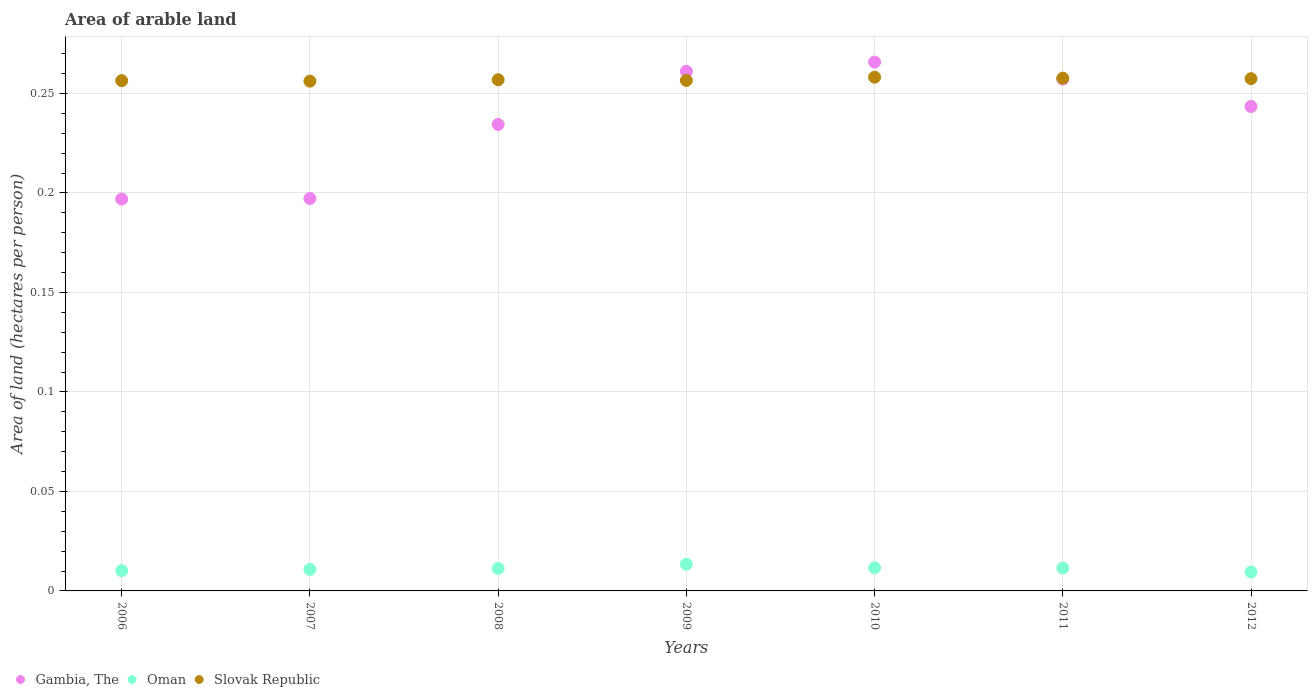What is the total arable land in Oman in 2008?
Keep it short and to the point. 0.01. Across all years, what is the maximum total arable land in Oman?
Ensure brevity in your answer.  0.01. Across all years, what is the minimum total arable land in Slovak Republic?
Keep it short and to the point. 0.26. What is the total total arable land in Oman in the graph?
Provide a short and direct response. 0.08. What is the difference between the total arable land in Oman in 2007 and that in 2008?
Make the answer very short. -0. What is the difference between the total arable land in Oman in 2006 and the total arable land in Slovak Republic in 2011?
Make the answer very short. -0.25. What is the average total arable land in Slovak Republic per year?
Make the answer very short. 0.26. In the year 2007, what is the difference between the total arable land in Oman and total arable land in Slovak Republic?
Your answer should be compact. -0.25. In how many years, is the total arable land in Slovak Republic greater than 0.15000000000000002 hectares per person?
Give a very brief answer. 7. What is the ratio of the total arable land in Gambia, The in 2007 to that in 2011?
Your answer should be very brief. 0.77. What is the difference between the highest and the second highest total arable land in Oman?
Your answer should be very brief. 0. What is the difference between the highest and the lowest total arable land in Slovak Republic?
Give a very brief answer. 0. In how many years, is the total arable land in Slovak Republic greater than the average total arable land in Slovak Republic taken over all years?
Provide a succinct answer. 3. Is the sum of the total arable land in Slovak Republic in 2008 and 2012 greater than the maximum total arable land in Oman across all years?
Offer a terse response. Yes. Is the total arable land in Slovak Republic strictly greater than the total arable land in Gambia, The over the years?
Your response must be concise. No. Is the total arable land in Oman strictly less than the total arable land in Slovak Republic over the years?
Make the answer very short. Yes. How many years are there in the graph?
Give a very brief answer. 7. What is the difference between two consecutive major ticks on the Y-axis?
Offer a terse response. 0.05. Are the values on the major ticks of Y-axis written in scientific E-notation?
Offer a terse response. No. Does the graph contain any zero values?
Provide a succinct answer. No. Does the graph contain grids?
Offer a terse response. Yes. Where does the legend appear in the graph?
Your answer should be compact. Bottom left. What is the title of the graph?
Your response must be concise. Area of arable land. Does "Guam" appear as one of the legend labels in the graph?
Provide a short and direct response. No. What is the label or title of the Y-axis?
Make the answer very short. Area of land (hectares per person). What is the Area of land (hectares per person) of Gambia, The in 2006?
Your answer should be compact. 0.2. What is the Area of land (hectares per person) in Oman in 2006?
Provide a short and direct response. 0.01. What is the Area of land (hectares per person) of Slovak Republic in 2006?
Offer a terse response. 0.26. What is the Area of land (hectares per person) in Gambia, The in 2007?
Make the answer very short. 0.2. What is the Area of land (hectares per person) of Oman in 2007?
Provide a short and direct response. 0.01. What is the Area of land (hectares per person) of Slovak Republic in 2007?
Provide a succinct answer. 0.26. What is the Area of land (hectares per person) of Gambia, The in 2008?
Provide a short and direct response. 0.23. What is the Area of land (hectares per person) in Oman in 2008?
Provide a short and direct response. 0.01. What is the Area of land (hectares per person) of Slovak Republic in 2008?
Provide a succinct answer. 0.26. What is the Area of land (hectares per person) of Gambia, The in 2009?
Ensure brevity in your answer.  0.26. What is the Area of land (hectares per person) of Oman in 2009?
Offer a terse response. 0.01. What is the Area of land (hectares per person) of Slovak Republic in 2009?
Keep it short and to the point. 0.26. What is the Area of land (hectares per person) of Gambia, The in 2010?
Provide a short and direct response. 0.27. What is the Area of land (hectares per person) of Oman in 2010?
Ensure brevity in your answer.  0.01. What is the Area of land (hectares per person) of Slovak Republic in 2010?
Make the answer very short. 0.26. What is the Area of land (hectares per person) in Gambia, The in 2011?
Give a very brief answer. 0.26. What is the Area of land (hectares per person) in Oman in 2011?
Make the answer very short. 0.01. What is the Area of land (hectares per person) of Slovak Republic in 2011?
Provide a short and direct response. 0.26. What is the Area of land (hectares per person) in Gambia, The in 2012?
Offer a very short reply. 0.24. What is the Area of land (hectares per person) in Oman in 2012?
Ensure brevity in your answer.  0.01. What is the Area of land (hectares per person) of Slovak Republic in 2012?
Make the answer very short. 0.26. Across all years, what is the maximum Area of land (hectares per person) in Gambia, The?
Keep it short and to the point. 0.27. Across all years, what is the maximum Area of land (hectares per person) in Oman?
Provide a succinct answer. 0.01. Across all years, what is the maximum Area of land (hectares per person) in Slovak Republic?
Give a very brief answer. 0.26. Across all years, what is the minimum Area of land (hectares per person) in Gambia, The?
Make the answer very short. 0.2. Across all years, what is the minimum Area of land (hectares per person) of Oman?
Give a very brief answer. 0.01. Across all years, what is the minimum Area of land (hectares per person) of Slovak Republic?
Offer a terse response. 0.26. What is the total Area of land (hectares per person) in Gambia, The in the graph?
Your answer should be very brief. 1.66. What is the total Area of land (hectares per person) of Oman in the graph?
Ensure brevity in your answer.  0.08. What is the total Area of land (hectares per person) in Slovak Republic in the graph?
Provide a short and direct response. 1.8. What is the difference between the Area of land (hectares per person) of Gambia, The in 2006 and that in 2007?
Keep it short and to the point. -0. What is the difference between the Area of land (hectares per person) of Oman in 2006 and that in 2007?
Give a very brief answer. -0. What is the difference between the Area of land (hectares per person) in Gambia, The in 2006 and that in 2008?
Keep it short and to the point. -0.04. What is the difference between the Area of land (hectares per person) of Oman in 2006 and that in 2008?
Ensure brevity in your answer.  -0. What is the difference between the Area of land (hectares per person) of Slovak Republic in 2006 and that in 2008?
Keep it short and to the point. -0. What is the difference between the Area of land (hectares per person) of Gambia, The in 2006 and that in 2009?
Your answer should be compact. -0.06. What is the difference between the Area of land (hectares per person) in Oman in 2006 and that in 2009?
Your response must be concise. -0. What is the difference between the Area of land (hectares per person) of Slovak Republic in 2006 and that in 2009?
Offer a terse response. -0. What is the difference between the Area of land (hectares per person) of Gambia, The in 2006 and that in 2010?
Your answer should be compact. -0.07. What is the difference between the Area of land (hectares per person) in Oman in 2006 and that in 2010?
Offer a terse response. -0. What is the difference between the Area of land (hectares per person) in Slovak Republic in 2006 and that in 2010?
Provide a short and direct response. -0. What is the difference between the Area of land (hectares per person) in Gambia, The in 2006 and that in 2011?
Keep it short and to the point. -0.06. What is the difference between the Area of land (hectares per person) in Oman in 2006 and that in 2011?
Give a very brief answer. -0. What is the difference between the Area of land (hectares per person) in Slovak Republic in 2006 and that in 2011?
Keep it short and to the point. -0. What is the difference between the Area of land (hectares per person) of Gambia, The in 2006 and that in 2012?
Provide a short and direct response. -0.05. What is the difference between the Area of land (hectares per person) of Oman in 2006 and that in 2012?
Keep it short and to the point. 0. What is the difference between the Area of land (hectares per person) of Slovak Republic in 2006 and that in 2012?
Your answer should be compact. -0. What is the difference between the Area of land (hectares per person) in Gambia, The in 2007 and that in 2008?
Your response must be concise. -0.04. What is the difference between the Area of land (hectares per person) of Oman in 2007 and that in 2008?
Keep it short and to the point. -0. What is the difference between the Area of land (hectares per person) of Slovak Republic in 2007 and that in 2008?
Provide a succinct answer. -0. What is the difference between the Area of land (hectares per person) of Gambia, The in 2007 and that in 2009?
Make the answer very short. -0.06. What is the difference between the Area of land (hectares per person) of Oman in 2007 and that in 2009?
Make the answer very short. -0. What is the difference between the Area of land (hectares per person) of Slovak Republic in 2007 and that in 2009?
Provide a succinct answer. -0. What is the difference between the Area of land (hectares per person) in Gambia, The in 2007 and that in 2010?
Offer a terse response. -0.07. What is the difference between the Area of land (hectares per person) of Oman in 2007 and that in 2010?
Make the answer very short. -0. What is the difference between the Area of land (hectares per person) of Slovak Republic in 2007 and that in 2010?
Your response must be concise. -0. What is the difference between the Area of land (hectares per person) of Gambia, The in 2007 and that in 2011?
Ensure brevity in your answer.  -0.06. What is the difference between the Area of land (hectares per person) in Oman in 2007 and that in 2011?
Provide a succinct answer. -0. What is the difference between the Area of land (hectares per person) of Slovak Republic in 2007 and that in 2011?
Give a very brief answer. -0. What is the difference between the Area of land (hectares per person) in Gambia, The in 2007 and that in 2012?
Offer a very short reply. -0.05. What is the difference between the Area of land (hectares per person) in Oman in 2007 and that in 2012?
Offer a very short reply. 0. What is the difference between the Area of land (hectares per person) in Slovak Republic in 2007 and that in 2012?
Your answer should be very brief. -0. What is the difference between the Area of land (hectares per person) of Gambia, The in 2008 and that in 2009?
Give a very brief answer. -0.03. What is the difference between the Area of land (hectares per person) of Oman in 2008 and that in 2009?
Provide a short and direct response. -0. What is the difference between the Area of land (hectares per person) in Gambia, The in 2008 and that in 2010?
Provide a succinct answer. -0.03. What is the difference between the Area of land (hectares per person) in Oman in 2008 and that in 2010?
Your response must be concise. -0. What is the difference between the Area of land (hectares per person) of Slovak Republic in 2008 and that in 2010?
Provide a short and direct response. -0. What is the difference between the Area of land (hectares per person) of Gambia, The in 2008 and that in 2011?
Your answer should be compact. -0.02. What is the difference between the Area of land (hectares per person) of Oman in 2008 and that in 2011?
Your answer should be very brief. -0. What is the difference between the Area of land (hectares per person) in Slovak Republic in 2008 and that in 2011?
Provide a succinct answer. -0. What is the difference between the Area of land (hectares per person) of Gambia, The in 2008 and that in 2012?
Give a very brief answer. -0.01. What is the difference between the Area of land (hectares per person) of Oman in 2008 and that in 2012?
Provide a short and direct response. 0. What is the difference between the Area of land (hectares per person) of Slovak Republic in 2008 and that in 2012?
Your answer should be very brief. -0. What is the difference between the Area of land (hectares per person) in Gambia, The in 2009 and that in 2010?
Offer a terse response. -0. What is the difference between the Area of land (hectares per person) of Oman in 2009 and that in 2010?
Your response must be concise. 0. What is the difference between the Area of land (hectares per person) in Slovak Republic in 2009 and that in 2010?
Make the answer very short. -0. What is the difference between the Area of land (hectares per person) in Gambia, The in 2009 and that in 2011?
Ensure brevity in your answer.  0. What is the difference between the Area of land (hectares per person) of Oman in 2009 and that in 2011?
Your response must be concise. 0. What is the difference between the Area of land (hectares per person) in Slovak Republic in 2009 and that in 2011?
Offer a terse response. -0. What is the difference between the Area of land (hectares per person) of Gambia, The in 2009 and that in 2012?
Offer a very short reply. 0.02. What is the difference between the Area of land (hectares per person) in Oman in 2009 and that in 2012?
Provide a short and direct response. 0. What is the difference between the Area of land (hectares per person) of Slovak Republic in 2009 and that in 2012?
Your answer should be very brief. -0. What is the difference between the Area of land (hectares per person) in Gambia, The in 2010 and that in 2011?
Ensure brevity in your answer.  0.01. What is the difference between the Area of land (hectares per person) of Gambia, The in 2010 and that in 2012?
Offer a terse response. 0.02. What is the difference between the Area of land (hectares per person) in Oman in 2010 and that in 2012?
Provide a short and direct response. 0. What is the difference between the Area of land (hectares per person) in Slovak Republic in 2010 and that in 2012?
Offer a very short reply. 0. What is the difference between the Area of land (hectares per person) of Gambia, The in 2011 and that in 2012?
Provide a short and direct response. 0.01. What is the difference between the Area of land (hectares per person) of Oman in 2011 and that in 2012?
Your answer should be compact. 0. What is the difference between the Area of land (hectares per person) in Slovak Republic in 2011 and that in 2012?
Your answer should be very brief. 0. What is the difference between the Area of land (hectares per person) in Gambia, The in 2006 and the Area of land (hectares per person) in Oman in 2007?
Ensure brevity in your answer.  0.19. What is the difference between the Area of land (hectares per person) of Gambia, The in 2006 and the Area of land (hectares per person) of Slovak Republic in 2007?
Offer a very short reply. -0.06. What is the difference between the Area of land (hectares per person) in Oman in 2006 and the Area of land (hectares per person) in Slovak Republic in 2007?
Give a very brief answer. -0.25. What is the difference between the Area of land (hectares per person) of Gambia, The in 2006 and the Area of land (hectares per person) of Oman in 2008?
Make the answer very short. 0.19. What is the difference between the Area of land (hectares per person) of Gambia, The in 2006 and the Area of land (hectares per person) of Slovak Republic in 2008?
Make the answer very short. -0.06. What is the difference between the Area of land (hectares per person) in Oman in 2006 and the Area of land (hectares per person) in Slovak Republic in 2008?
Your answer should be very brief. -0.25. What is the difference between the Area of land (hectares per person) of Gambia, The in 2006 and the Area of land (hectares per person) of Oman in 2009?
Your response must be concise. 0.18. What is the difference between the Area of land (hectares per person) in Gambia, The in 2006 and the Area of land (hectares per person) in Slovak Republic in 2009?
Your answer should be very brief. -0.06. What is the difference between the Area of land (hectares per person) of Oman in 2006 and the Area of land (hectares per person) of Slovak Republic in 2009?
Keep it short and to the point. -0.25. What is the difference between the Area of land (hectares per person) in Gambia, The in 2006 and the Area of land (hectares per person) in Oman in 2010?
Offer a terse response. 0.19. What is the difference between the Area of land (hectares per person) of Gambia, The in 2006 and the Area of land (hectares per person) of Slovak Republic in 2010?
Your answer should be very brief. -0.06. What is the difference between the Area of land (hectares per person) in Oman in 2006 and the Area of land (hectares per person) in Slovak Republic in 2010?
Make the answer very short. -0.25. What is the difference between the Area of land (hectares per person) of Gambia, The in 2006 and the Area of land (hectares per person) of Oman in 2011?
Ensure brevity in your answer.  0.19. What is the difference between the Area of land (hectares per person) of Gambia, The in 2006 and the Area of land (hectares per person) of Slovak Republic in 2011?
Provide a succinct answer. -0.06. What is the difference between the Area of land (hectares per person) of Oman in 2006 and the Area of land (hectares per person) of Slovak Republic in 2011?
Keep it short and to the point. -0.25. What is the difference between the Area of land (hectares per person) in Gambia, The in 2006 and the Area of land (hectares per person) in Oman in 2012?
Provide a short and direct response. 0.19. What is the difference between the Area of land (hectares per person) in Gambia, The in 2006 and the Area of land (hectares per person) in Slovak Republic in 2012?
Your response must be concise. -0.06. What is the difference between the Area of land (hectares per person) in Oman in 2006 and the Area of land (hectares per person) in Slovak Republic in 2012?
Offer a terse response. -0.25. What is the difference between the Area of land (hectares per person) in Gambia, The in 2007 and the Area of land (hectares per person) in Oman in 2008?
Make the answer very short. 0.19. What is the difference between the Area of land (hectares per person) in Gambia, The in 2007 and the Area of land (hectares per person) in Slovak Republic in 2008?
Make the answer very short. -0.06. What is the difference between the Area of land (hectares per person) in Oman in 2007 and the Area of land (hectares per person) in Slovak Republic in 2008?
Your answer should be very brief. -0.25. What is the difference between the Area of land (hectares per person) in Gambia, The in 2007 and the Area of land (hectares per person) in Oman in 2009?
Ensure brevity in your answer.  0.18. What is the difference between the Area of land (hectares per person) of Gambia, The in 2007 and the Area of land (hectares per person) of Slovak Republic in 2009?
Offer a very short reply. -0.06. What is the difference between the Area of land (hectares per person) of Oman in 2007 and the Area of land (hectares per person) of Slovak Republic in 2009?
Provide a succinct answer. -0.25. What is the difference between the Area of land (hectares per person) of Gambia, The in 2007 and the Area of land (hectares per person) of Oman in 2010?
Provide a succinct answer. 0.19. What is the difference between the Area of land (hectares per person) of Gambia, The in 2007 and the Area of land (hectares per person) of Slovak Republic in 2010?
Your answer should be compact. -0.06. What is the difference between the Area of land (hectares per person) in Oman in 2007 and the Area of land (hectares per person) in Slovak Republic in 2010?
Your answer should be very brief. -0.25. What is the difference between the Area of land (hectares per person) in Gambia, The in 2007 and the Area of land (hectares per person) in Oman in 2011?
Provide a short and direct response. 0.19. What is the difference between the Area of land (hectares per person) in Gambia, The in 2007 and the Area of land (hectares per person) in Slovak Republic in 2011?
Give a very brief answer. -0.06. What is the difference between the Area of land (hectares per person) in Oman in 2007 and the Area of land (hectares per person) in Slovak Republic in 2011?
Make the answer very short. -0.25. What is the difference between the Area of land (hectares per person) in Gambia, The in 2007 and the Area of land (hectares per person) in Oman in 2012?
Make the answer very short. 0.19. What is the difference between the Area of land (hectares per person) of Gambia, The in 2007 and the Area of land (hectares per person) of Slovak Republic in 2012?
Ensure brevity in your answer.  -0.06. What is the difference between the Area of land (hectares per person) of Oman in 2007 and the Area of land (hectares per person) of Slovak Republic in 2012?
Provide a succinct answer. -0.25. What is the difference between the Area of land (hectares per person) of Gambia, The in 2008 and the Area of land (hectares per person) of Oman in 2009?
Ensure brevity in your answer.  0.22. What is the difference between the Area of land (hectares per person) of Gambia, The in 2008 and the Area of land (hectares per person) of Slovak Republic in 2009?
Your answer should be very brief. -0.02. What is the difference between the Area of land (hectares per person) of Oman in 2008 and the Area of land (hectares per person) of Slovak Republic in 2009?
Your response must be concise. -0.25. What is the difference between the Area of land (hectares per person) of Gambia, The in 2008 and the Area of land (hectares per person) of Oman in 2010?
Ensure brevity in your answer.  0.22. What is the difference between the Area of land (hectares per person) of Gambia, The in 2008 and the Area of land (hectares per person) of Slovak Republic in 2010?
Keep it short and to the point. -0.02. What is the difference between the Area of land (hectares per person) of Oman in 2008 and the Area of land (hectares per person) of Slovak Republic in 2010?
Your answer should be compact. -0.25. What is the difference between the Area of land (hectares per person) in Gambia, The in 2008 and the Area of land (hectares per person) in Oman in 2011?
Provide a short and direct response. 0.22. What is the difference between the Area of land (hectares per person) in Gambia, The in 2008 and the Area of land (hectares per person) in Slovak Republic in 2011?
Ensure brevity in your answer.  -0.02. What is the difference between the Area of land (hectares per person) in Oman in 2008 and the Area of land (hectares per person) in Slovak Republic in 2011?
Your answer should be compact. -0.25. What is the difference between the Area of land (hectares per person) in Gambia, The in 2008 and the Area of land (hectares per person) in Oman in 2012?
Give a very brief answer. 0.22. What is the difference between the Area of land (hectares per person) of Gambia, The in 2008 and the Area of land (hectares per person) of Slovak Republic in 2012?
Your answer should be very brief. -0.02. What is the difference between the Area of land (hectares per person) of Oman in 2008 and the Area of land (hectares per person) of Slovak Republic in 2012?
Give a very brief answer. -0.25. What is the difference between the Area of land (hectares per person) in Gambia, The in 2009 and the Area of land (hectares per person) in Oman in 2010?
Offer a terse response. 0.25. What is the difference between the Area of land (hectares per person) of Gambia, The in 2009 and the Area of land (hectares per person) of Slovak Republic in 2010?
Your answer should be compact. 0. What is the difference between the Area of land (hectares per person) in Oman in 2009 and the Area of land (hectares per person) in Slovak Republic in 2010?
Provide a short and direct response. -0.24. What is the difference between the Area of land (hectares per person) of Gambia, The in 2009 and the Area of land (hectares per person) of Oman in 2011?
Your answer should be very brief. 0.25. What is the difference between the Area of land (hectares per person) in Gambia, The in 2009 and the Area of land (hectares per person) in Slovak Republic in 2011?
Your answer should be compact. 0. What is the difference between the Area of land (hectares per person) in Oman in 2009 and the Area of land (hectares per person) in Slovak Republic in 2011?
Keep it short and to the point. -0.24. What is the difference between the Area of land (hectares per person) in Gambia, The in 2009 and the Area of land (hectares per person) in Oman in 2012?
Keep it short and to the point. 0.25. What is the difference between the Area of land (hectares per person) in Gambia, The in 2009 and the Area of land (hectares per person) in Slovak Republic in 2012?
Give a very brief answer. 0. What is the difference between the Area of land (hectares per person) of Oman in 2009 and the Area of land (hectares per person) of Slovak Republic in 2012?
Offer a terse response. -0.24. What is the difference between the Area of land (hectares per person) of Gambia, The in 2010 and the Area of land (hectares per person) of Oman in 2011?
Ensure brevity in your answer.  0.25. What is the difference between the Area of land (hectares per person) in Gambia, The in 2010 and the Area of land (hectares per person) in Slovak Republic in 2011?
Your answer should be compact. 0.01. What is the difference between the Area of land (hectares per person) in Oman in 2010 and the Area of land (hectares per person) in Slovak Republic in 2011?
Provide a succinct answer. -0.25. What is the difference between the Area of land (hectares per person) of Gambia, The in 2010 and the Area of land (hectares per person) of Oman in 2012?
Ensure brevity in your answer.  0.26. What is the difference between the Area of land (hectares per person) of Gambia, The in 2010 and the Area of land (hectares per person) of Slovak Republic in 2012?
Make the answer very short. 0.01. What is the difference between the Area of land (hectares per person) in Oman in 2010 and the Area of land (hectares per person) in Slovak Republic in 2012?
Make the answer very short. -0.25. What is the difference between the Area of land (hectares per person) in Gambia, The in 2011 and the Area of land (hectares per person) in Oman in 2012?
Give a very brief answer. 0.25. What is the difference between the Area of land (hectares per person) of Gambia, The in 2011 and the Area of land (hectares per person) of Slovak Republic in 2012?
Your answer should be compact. -0. What is the difference between the Area of land (hectares per person) in Oman in 2011 and the Area of land (hectares per person) in Slovak Republic in 2012?
Offer a terse response. -0.25. What is the average Area of land (hectares per person) of Gambia, The per year?
Keep it short and to the point. 0.24. What is the average Area of land (hectares per person) of Oman per year?
Offer a very short reply. 0.01. What is the average Area of land (hectares per person) in Slovak Republic per year?
Ensure brevity in your answer.  0.26. In the year 2006, what is the difference between the Area of land (hectares per person) in Gambia, The and Area of land (hectares per person) in Oman?
Make the answer very short. 0.19. In the year 2006, what is the difference between the Area of land (hectares per person) of Gambia, The and Area of land (hectares per person) of Slovak Republic?
Provide a succinct answer. -0.06. In the year 2006, what is the difference between the Area of land (hectares per person) in Oman and Area of land (hectares per person) in Slovak Republic?
Provide a succinct answer. -0.25. In the year 2007, what is the difference between the Area of land (hectares per person) of Gambia, The and Area of land (hectares per person) of Oman?
Make the answer very short. 0.19. In the year 2007, what is the difference between the Area of land (hectares per person) of Gambia, The and Area of land (hectares per person) of Slovak Republic?
Provide a succinct answer. -0.06. In the year 2007, what is the difference between the Area of land (hectares per person) of Oman and Area of land (hectares per person) of Slovak Republic?
Keep it short and to the point. -0.25. In the year 2008, what is the difference between the Area of land (hectares per person) in Gambia, The and Area of land (hectares per person) in Oman?
Make the answer very short. 0.22. In the year 2008, what is the difference between the Area of land (hectares per person) in Gambia, The and Area of land (hectares per person) in Slovak Republic?
Offer a terse response. -0.02. In the year 2008, what is the difference between the Area of land (hectares per person) of Oman and Area of land (hectares per person) of Slovak Republic?
Ensure brevity in your answer.  -0.25. In the year 2009, what is the difference between the Area of land (hectares per person) in Gambia, The and Area of land (hectares per person) in Oman?
Give a very brief answer. 0.25. In the year 2009, what is the difference between the Area of land (hectares per person) in Gambia, The and Area of land (hectares per person) in Slovak Republic?
Provide a short and direct response. 0. In the year 2009, what is the difference between the Area of land (hectares per person) of Oman and Area of land (hectares per person) of Slovak Republic?
Make the answer very short. -0.24. In the year 2010, what is the difference between the Area of land (hectares per person) of Gambia, The and Area of land (hectares per person) of Oman?
Provide a short and direct response. 0.25. In the year 2010, what is the difference between the Area of land (hectares per person) of Gambia, The and Area of land (hectares per person) of Slovak Republic?
Give a very brief answer. 0.01. In the year 2010, what is the difference between the Area of land (hectares per person) of Oman and Area of land (hectares per person) of Slovak Republic?
Offer a terse response. -0.25. In the year 2011, what is the difference between the Area of land (hectares per person) of Gambia, The and Area of land (hectares per person) of Oman?
Your response must be concise. 0.25. In the year 2011, what is the difference between the Area of land (hectares per person) in Gambia, The and Area of land (hectares per person) in Slovak Republic?
Keep it short and to the point. -0. In the year 2011, what is the difference between the Area of land (hectares per person) of Oman and Area of land (hectares per person) of Slovak Republic?
Offer a terse response. -0.25. In the year 2012, what is the difference between the Area of land (hectares per person) of Gambia, The and Area of land (hectares per person) of Oman?
Provide a succinct answer. 0.23. In the year 2012, what is the difference between the Area of land (hectares per person) of Gambia, The and Area of land (hectares per person) of Slovak Republic?
Offer a very short reply. -0.01. In the year 2012, what is the difference between the Area of land (hectares per person) in Oman and Area of land (hectares per person) in Slovak Republic?
Your answer should be compact. -0.25. What is the ratio of the Area of land (hectares per person) in Gambia, The in 2006 to that in 2007?
Offer a terse response. 1. What is the ratio of the Area of land (hectares per person) in Oman in 2006 to that in 2007?
Provide a succinct answer. 0.94. What is the ratio of the Area of land (hectares per person) in Slovak Republic in 2006 to that in 2007?
Keep it short and to the point. 1. What is the ratio of the Area of land (hectares per person) of Gambia, The in 2006 to that in 2008?
Give a very brief answer. 0.84. What is the ratio of the Area of land (hectares per person) in Oman in 2006 to that in 2008?
Offer a very short reply. 0.9. What is the ratio of the Area of land (hectares per person) in Gambia, The in 2006 to that in 2009?
Make the answer very short. 0.75. What is the ratio of the Area of land (hectares per person) of Oman in 2006 to that in 2009?
Provide a short and direct response. 0.76. What is the ratio of the Area of land (hectares per person) in Slovak Republic in 2006 to that in 2009?
Your answer should be compact. 1. What is the ratio of the Area of land (hectares per person) of Gambia, The in 2006 to that in 2010?
Make the answer very short. 0.74. What is the ratio of the Area of land (hectares per person) of Oman in 2006 to that in 2010?
Provide a short and direct response. 0.87. What is the ratio of the Area of land (hectares per person) in Gambia, The in 2006 to that in 2011?
Make the answer very short. 0.77. What is the ratio of the Area of land (hectares per person) in Oman in 2006 to that in 2011?
Make the answer very short. 0.89. What is the ratio of the Area of land (hectares per person) of Gambia, The in 2006 to that in 2012?
Your answer should be compact. 0.81. What is the ratio of the Area of land (hectares per person) of Oman in 2006 to that in 2012?
Your response must be concise. 1.07. What is the ratio of the Area of land (hectares per person) of Slovak Republic in 2006 to that in 2012?
Make the answer very short. 1. What is the ratio of the Area of land (hectares per person) in Gambia, The in 2007 to that in 2008?
Offer a terse response. 0.84. What is the ratio of the Area of land (hectares per person) in Oman in 2007 to that in 2008?
Ensure brevity in your answer.  0.95. What is the ratio of the Area of land (hectares per person) of Gambia, The in 2007 to that in 2009?
Offer a terse response. 0.76. What is the ratio of the Area of land (hectares per person) of Oman in 2007 to that in 2009?
Offer a terse response. 0.81. What is the ratio of the Area of land (hectares per person) in Gambia, The in 2007 to that in 2010?
Make the answer very short. 0.74. What is the ratio of the Area of land (hectares per person) in Oman in 2007 to that in 2010?
Your answer should be compact. 0.93. What is the ratio of the Area of land (hectares per person) of Gambia, The in 2007 to that in 2011?
Offer a very short reply. 0.77. What is the ratio of the Area of land (hectares per person) in Oman in 2007 to that in 2011?
Provide a succinct answer. 0.94. What is the ratio of the Area of land (hectares per person) in Gambia, The in 2007 to that in 2012?
Your answer should be very brief. 0.81. What is the ratio of the Area of land (hectares per person) in Oman in 2007 to that in 2012?
Offer a terse response. 1.14. What is the ratio of the Area of land (hectares per person) of Gambia, The in 2008 to that in 2009?
Keep it short and to the point. 0.9. What is the ratio of the Area of land (hectares per person) in Oman in 2008 to that in 2009?
Offer a terse response. 0.84. What is the ratio of the Area of land (hectares per person) of Slovak Republic in 2008 to that in 2009?
Your answer should be compact. 1. What is the ratio of the Area of land (hectares per person) in Gambia, The in 2008 to that in 2010?
Ensure brevity in your answer.  0.88. What is the ratio of the Area of land (hectares per person) of Oman in 2008 to that in 2010?
Keep it short and to the point. 0.97. What is the ratio of the Area of land (hectares per person) in Gambia, The in 2008 to that in 2011?
Provide a short and direct response. 0.91. What is the ratio of the Area of land (hectares per person) of Oman in 2008 to that in 2011?
Your answer should be very brief. 0.98. What is the ratio of the Area of land (hectares per person) of Gambia, The in 2008 to that in 2012?
Keep it short and to the point. 0.96. What is the ratio of the Area of land (hectares per person) in Oman in 2008 to that in 2012?
Give a very brief answer. 1.19. What is the ratio of the Area of land (hectares per person) of Gambia, The in 2009 to that in 2010?
Your answer should be very brief. 0.98. What is the ratio of the Area of land (hectares per person) in Oman in 2009 to that in 2010?
Give a very brief answer. 1.15. What is the ratio of the Area of land (hectares per person) in Gambia, The in 2009 to that in 2011?
Give a very brief answer. 1.02. What is the ratio of the Area of land (hectares per person) in Oman in 2009 to that in 2011?
Your answer should be compact. 1.17. What is the ratio of the Area of land (hectares per person) in Slovak Republic in 2009 to that in 2011?
Your answer should be compact. 1. What is the ratio of the Area of land (hectares per person) in Gambia, The in 2009 to that in 2012?
Offer a terse response. 1.07. What is the ratio of the Area of land (hectares per person) in Oman in 2009 to that in 2012?
Ensure brevity in your answer.  1.41. What is the ratio of the Area of land (hectares per person) of Slovak Republic in 2009 to that in 2012?
Keep it short and to the point. 1. What is the ratio of the Area of land (hectares per person) of Gambia, The in 2010 to that in 2011?
Give a very brief answer. 1.03. What is the ratio of the Area of land (hectares per person) in Oman in 2010 to that in 2011?
Your response must be concise. 1.01. What is the ratio of the Area of land (hectares per person) in Gambia, The in 2010 to that in 2012?
Give a very brief answer. 1.09. What is the ratio of the Area of land (hectares per person) of Oman in 2010 to that in 2012?
Make the answer very short. 1.23. What is the ratio of the Area of land (hectares per person) in Slovak Republic in 2010 to that in 2012?
Your response must be concise. 1. What is the ratio of the Area of land (hectares per person) of Gambia, The in 2011 to that in 2012?
Your answer should be compact. 1.06. What is the ratio of the Area of land (hectares per person) in Oman in 2011 to that in 2012?
Keep it short and to the point. 1.21. What is the ratio of the Area of land (hectares per person) in Slovak Republic in 2011 to that in 2012?
Provide a short and direct response. 1. What is the difference between the highest and the second highest Area of land (hectares per person) in Gambia, The?
Make the answer very short. 0. What is the difference between the highest and the second highest Area of land (hectares per person) of Oman?
Make the answer very short. 0. What is the difference between the highest and the lowest Area of land (hectares per person) of Gambia, The?
Ensure brevity in your answer.  0.07. What is the difference between the highest and the lowest Area of land (hectares per person) in Oman?
Provide a short and direct response. 0. What is the difference between the highest and the lowest Area of land (hectares per person) in Slovak Republic?
Give a very brief answer. 0. 